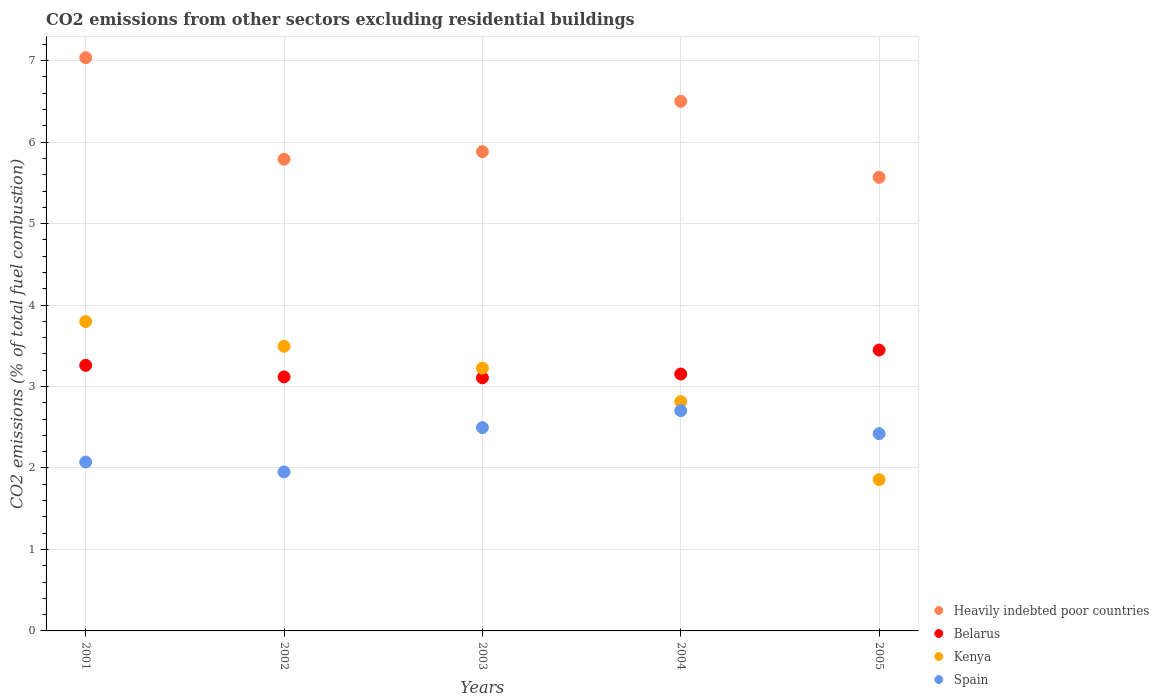How many different coloured dotlines are there?
Provide a succinct answer. 4. Is the number of dotlines equal to the number of legend labels?
Make the answer very short. Yes. What is the total CO2 emitted in Kenya in 2001?
Give a very brief answer. 3.8. Across all years, what is the maximum total CO2 emitted in Kenya?
Ensure brevity in your answer.  3.8. Across all years, what is the minimum total CO2 emitted in Spain?
Offer a terse response. 1.95. In which year was the total CO2 emitted in Spain maximum?
Keep it short and to the point. 2004. What is the total total CO2 emitted in Belarus in the graph?
Provide a succinct answer. 16.09. What is the difference between the total CO2 emitted in Spain in 2001 and that in 2003?
Make the answer very short. -0.42. What is the difference between the total CO2 emitted in Spain in 2002 and the total CO2 emitted in Belarus in 2005?
Ensure brevity in your answer.  -1.5. What is the average total CO2 emitted in Spain per year?
Keep it short and to the point. 2.33. In the year 2003, what is the difference between the total CO2 emitted in Kenya and total CO2 emitted in Spain?
Ensure brevity in your answer.  0.73. In how many years, is the total CO2 emitted in Kenya greater than 6?
Offer a very short reply. 0. What is the ratio of the total CO2 emitted in Belarus in 2002 to that in 2003?
Offer a very short reply. 1. Is the difference between the total CO2 emitted in Kenya in 2001 and 2005 greater than the difference between the total CO2 emitted in Spain in 2001 and 2005?
Your response must be concise. Yes. What is the difference between the highest and the second highest total CO2 emitted in Heavily indebted poor countries?
Your answer should be very brief. 0.54. What is the difference between the highest and the lowest total CO2 emitted in Kenya?
Offer a terse response. 1.94. Is the sum of the total CO2 emitted in Spain in 2001 and 2005 greater than the maximum total CO2 emitted in Heavily indebted poor countries across all years?
Your answer should be compact. No. Is it the case that in every year, the sum of the total CO2 emitted in Heavily indebted poor countries and total CO2 emitted in Kenya  is greater than the sum of total CO2 emitted in Spain and total CO2 emitted in Belarus?
Your response must be concise. Yes. How many dotlines are there?
Keep it short and to the point. 4. How many years are there in the graph?
Offer a very short reply. 5. Are the values on the major ticks of Y-axis written in scientific E-notation?
Provide a short and direct response. No. Does the graph contain grids?
Give a very brief answer. Yes. Where does the legend appear in the graph?
Give a very brief answer. Bottom right. What is the title of the graph?
Ensure brevity in your answer.  CO2 emissions from other sectors excluding residential buildings. What is the label or title of the Y-axis?
Your answer should be compact. CO2 emissions (% of total fuel combustion). What is the CO2 emissions (% of total fuel combustion) in Heavily indebted poor countries in 2001?
Provide a succinct answer. 7.04. What is the CO2 emissions (% of total fuel combustion) of Belarus in 2001?
Provide a short and direct response. 3.26. What is the CO2 emissions (% of total fuel combustion) of Kenya in 2001?
Make the answer very short. 3.8. What is the CO2 emissions (% of total fuel combustion) of Spain in 2001?
Offer a very short reply. 2.07. What is the CO2 emissions (% of total fuel combustion) in Heavily indebted poor countries in 2002?
Provide a succinct answer. 5.79. What is the CO2 emissions (% of total fuel combustion) in Belarus in 2002?
Your answer should be very brief. 3.12. What is the CO2 emissions (% of total fuel combustion) of Kenya in 2002?
Offer a very short reply. 3.49. What is the CO2 emissions (% of total fuel combustion) of Spain in 2002?
Make the answer very short. 1.95. What is the CO2 emissions (% of total fuel combustion) in Heavily indebted poor countries in 2003?
Make the answer very short. 5.88. What is the CO2 emissions (% of total fuel combustion) in Belarus in 2003?
Give a very brief answer. 3.11. What is the CO2 emissions (% of total fuel combustion) in Kenya in 2003?
Your response must be concise. 3.23. What is the CO2 emissions (% of total fuel combustion) of Spain in 2003?
Give a very brief answer. 2.5. What is the CO2 emissions (% of total fuel combustion) in Heavily indebted poor countries in 2004?
Your response must be concise. 6.5. What is the CO2 emissions (% of total fuel combustion) of Belarus in 2004?
Ensure brevity in your answer.  3.15. What is the CO2 emissions (% of total fuel combustion) in Kenya in 2004?
Offer a very short reply. 2.81. What is the CO2 emissions (% of total fuel combustion) in Spain in 2004?
Make the answer very short. 2.7. What is the CO2 emissions (% of total fuel combustion) in Heavily indebted poor countries in 2005?
Your answer should be compact. 5.57. What is the CO2 emissions (% of total fuel combustion) in Belarus in 2005?
Keep it short and to the point. 3.45. What is the CO2 emissions (% of total fuel combustion) in Kenya in 2005?
Keep it short and to the point. 1.86. What is the CO2 emissions (% of total fuel combustion) of Spain in 2005?
Offer a terse response. 2.42. Across all years, what is the maximum CO2 emissions (% of total fuel combustion) in Heavily indebted poor countries?
Offer a very short reply. 7.04. Across all years, what is the maximum CO2 emissions (% of total fuel combustion) of Belarus?
Make the answer very short. 3.45. Across all years, what is the maximum CO2 emissions (% of total fuel combustion) of Kenya?
Keep it short and to the point. 3.8. Across all years, what is the maximum CO2 emissions (% of total fuel combustion) of Spain?
Keep it short and to the point. 2.7. Across all years, what is the minimum CO2 emissions (% of total fuel combustion) of Heavily indebted poor countries?
Give a very brief answer. 5.57. Across all years, what is the minimum CO2 emissions (% of total fuel combustion) in Belarus?
Ensure brevity in your answer.  3.11. Across all years, what is the minimum CO2 emissions (% of total fuel combustion) of Kenya?
Offer a terse response. 1.86. Across all years, what is the minimum CO2 emissions (% of total fuel combustion) in Spain?
Offer a terse response. 1.95. What is the total CO2 emissions (% of total fuel combustion) of Heavily indebted poor countries in the graph?
Provide a succinct answer. 30.78. What is the total CO2 emissions (% of total fuel combustion) in Belarus in the graph?
Provide a succinct answer. 16.09. What is the total CO2 emissions (% of total fuel combustion) of Kenya in the graph?
Offer a terse response. 15.19. What is the total CO2 emissions (% of total fuel combustion) in Spain in the graph?
Give a very brief answer. 11.65. What is the difference between the CO2 emissions (% of total fuel combustion) in Heavily indebted poor countries in 2001 and that in 2002?
Provide a short and direct response. 1.25. What is the difference between the CO2 emissions (% of total fuel combustion) in Belarus in 2001 and that in 2002?
Offer a very short reply. 0.14. What is the difference between the CO2 emissions (% of total fuel combustion) in Kenya in 2001 and that in 2002?
Your answer should be compact. 0.3. What is the difference between the CO2 emissions (% of total fuel combustion) in Spain in 2001 and that in 2002?
Keep it short and to the point. 0.12. What is the difference between the CO2 emissions (% of total fuel combustion) in Heavily indebted poor countries in 2001 and that in 2003?
Offer a terse response. 1.15. What is the difference between the CO2 emissions (% of total fuel combustion) of Belarus in 2001 and that in 2003?
Keep it short and to the point. 0.15. What is the difference between the CO2 emissions (% of total fuel combustion) in Kenya in 2001 and that in 2003?
Provide a short and direct response. 0.57. What is the difference between the CO2 emissions (% of total fuel combustion) in Spain in 2001 and that in 2003?
Give a very brief answer. -0.42. What is the difference between the CO2 emissions (% of total fuel combustion) of Heavily indebted poor countries in 2001 and that in 2004?
Your response must be concise. 0.54. What is the difference between the CO2 emissions (% of total fuel combustion) in Belarus in 2001 and that in 2004?
Offer a terse response. 0.11. What is the difference between the CO2 emissions (% of total fuel combustion) of Kenya in 2001 and that in 2004?
Provide a short and direct response. 0.98. What is the difference between the CO2 emissions (% of total fuel combustion) of Spain in 2001 and that in 2004?
Offer a very short reply. -0.63. What is the difference between the CO2 emissions (% of total fuel combustion) of Heavily indebted poor countries in 2001 and that in 2005?
Give a very brief answer. 1.47. What is the difference between the CO2 emissions (% of total fuel combustion) of Belarus in 2001 and that in 2005?
Keep it short and to the point. -0.19. What is the difference between the CO2 emissions (% of total fuel combustion) in Kenya in 2001 and that in 2005?
Offer a very short reply. 1.94. What is the difference between the CO2 emissions (% of total fuel combustion) in Spain in 2001 and that in 2005?
Keep it short and to the point. -0.35. What is the difference between the CO2 emissions (% of total fuel combustion) of Heavily indebted poor countries in 2002 and that in 2003?
Make the answer very short. -0.09. What is the difference between the CO2 emissions (% of total fuel combustion) of Belarus in 2002 and that in 2003?
Offer a very short reply. 0.01. What is the difference between the CO2 emissions (% of total fuel combustion) in Kenya in 2002 and that in 2003?
Provide a succinct answer. 0.27. What is the difference between the CO2 emissions (% of total fuel combustion) of Spain in 2002 and that in 2003?
Provide a succinct answer. -0.54. What is the difference between the CO2 emissions (% of total fuel combustion) in Heavily indebted poor countries in 2002 and that in 2004?
Make the answer very short. -0.71. What is the difference between the CO2 emissions (% of total fuel combustion) of Belarus in 2002 and that in 2004?
Offer a terse response. -0.04. What is the difference between the CO2 emissions (% of total fuel combustion) in Kenya in 2002 and that in 2004?
Your response must be concise. 0.68. What is the difference between the CO2 emissions (% of total fuel combustion) in Spain in 2002 and that in 2004?
Offer a very short reply. -0.75. What is the difference between the CO2 emissions (% of total fuel combustion) of Heavily indebted poor countries in 2002 and that in 2005?
Make the answer very short. 0.22. What is the difference between the CO2 emissions (% of total fuel combustion) of Belarus in 2002 and that in 2005?
Provide a succinct answer. -0.33. What is the difference between the CO2 emissions (% of total fuel combustion) in Kenya in 2002 and that in 2005?
Ensure brevity in your answer.  1.64. What is the difference between the CO2 emissions (% of total fuel combustion) of Spain in 2002 and that in 2005?
Offer a terse response. -0.47. What is the difference between the CO2 emissions (% of total fuel combustion) of Heavily indebted poor countries in 2003 and that in 2004?
Your response must be concise. -0.62. What is the difference between the CO2 emissions (% of total fuel combustion) in Belarus in 2003 and that in 2004?
Offer a terse response. -0.05. What is the difference between the CO2 emissions (% of total fuel combustion) of Kenya in 2003 and that in 2004?
Your answer should be compact. 0.41. What is the difference between the CO2 emissions (% of total fuel combustion) of Spain in 2003 and that in 2004?
Give a very brief answer. -0.21. What is the difference between the CO2 emissions (% of total fuel combustion) in Heavily indebted poor countries in 2003 and that in 2005?
Make the answer very short. 0.32. What is the difference between the CO2 emissions (% of total fuel combustion) of Belarus in 2003 and that in 2005?
Ensure brevity in your answer.  -0.34. What is the difference between the CO2 emissions (% of total fuel combustion) of Kenya in 2003 and that in 2005?
Offer a terse response. 1.37. What is the difference between the CO2 emissions (% of total fuel combustion) of Spain in 2003 and that in 2005?
Your answer should be very brief. 0.07. What is the difference between the CO2 emissions (% of total fuel combustion) in Heavily indebted poor countries in 2004 and that in 2005?
Your response must be concise. 0.93. What is the difference between the CO2 emissions (% of total fuel combustion) in Belarus in 2004 and that in 2005?
Keep it short and to the point. -0.29. What is the difference between the CO2 emissions (% of total fuel combustion) in Kenya in 2004 and that in 2005?
Your answer should be compact. 0.96. What is the difference between the CO2 emissions (% of total fuel combustion) in Spain in 2004 and that in 2005?
Offer a terse response. 0.28. What is the difference between the CO2 emissions (% of total fuel combustion) in Heavily indebted poor countries in 2001 and the CO2 emissions (% of total fuel combustion) in Belarus in 2002?
Give a very brief answer. 3.92. What is the difference between the CO2 emissions (% of total fuel combustion) of Heavily indebted poor countries in 2001 and the CO2 emissions (% of total fuel combustion) of Kenya in 2002?
Your answer should be compact. 3.54. What is the difference between the CO2 emissions (% of total fuel combustion) of Heavily indebted poor countries in 2001 and the CO2 emissions (% of total fuel combustion) of Spain in 2002?
Provide a short and direct response. 5.08. What is the difference between the CO2 emissions (% of total fuel combustion) in Belarus in 2001 and the CO2 emissions (% of total fuel combustion) in Kenya in 2002?
Offer a terse response. -0.23. What is the difference between the CO2 emissions (% of total fuel combustion) of Belarus in 2001 and the CO2 emissions (% of total fuel combustion) of Spain in 2002?
Your answer should be very brief. 1.31. What is the difference between the CO2 emissions (% of total fuel combustion) of Kenya in 2001 and the CO2 emissions (% of total fuel combustion) of Spain in 2002?
Make the answer very short. 1.85. What is the difference between the CO2 emissions (% of total fuel combustion) of Heavily indebted poor countries in 2001 and the CO2 emissions (% of total fuel combustion) of Belarus in 2003?
Provide a short and direct response. 3.93. What is the difference between the CO2 emissions (% of total fuel combustion) in Heavily indebted poor countries in 2001 and the CO2 emissions (% of total fuel combustion) in Kenya in 2003?
Ensure brevity in your answer.  3.81. What is the difference between the CO2 emissions (% of total fuel combustion) in Heavily indebted poor countries in 2001 and the CO2 emissions (% of total fuel combustion) in Spain in 2003?
Keep it short and to the point. 4.54. What is the difference between the CO2 emissions (% of total fuel combustion) in Belarus in 2001 and the CO2 emissions (% of total fuel combustion) in Kenya in 2003?
Offer a very short reply. 0.03. What is the difference between the CO2 emissions (% of total fuel combustion) in Belarus in 2001 and the CO2 emissions (% of total fuel combustion) in Spain in 2003?
Provide a succinct answer. 0.76. What is the difference between the CO2 emissions (% of total fuel combustion) in Kenya in 2001 and the CO2 emissions (% of total fuel combustion) in Spain in 2003?
Offer a very short reply. 1.3. What is the difference between the CO2 emissions (% of total fuel combustion) in Heavily indebted poor countries in 2001 and the CO2 emissions (% of total fuel combustion) in Belarus in 2004?
Offer a very short reply. 3.88. What is the difference between the CO2 emissions (% of total fuel combustion) in Heavily indebted poor countries in 2001 and the CO2 emissions (% of total fuel combustion) in Kenya in 2004?
Provide a succinct answer. 4.22. What is the difference between the CO2 emissions (% of total fuel combustion) of Heavily indebted poor countries in 2001 and the CO2 emissions (% of total fuel combustion) of Spain in 2004?
Provide a succinct answer. 4.33. What is the difference between the CO2 emissions (% of total fuel combustion) of Belarus in 2001 and the CO2 emissions (% of total fuel combustion) of Kenya in 2004?
Your answer should be compact. 0.45. What is the difference between the CO2 emissions (% of total fuel combustion) in Belarus in 2001 and the CO2 emissions (% of total fuel combustion) in Spain in 2004?
Your answer should be compact. 0.56. What is the difference between the CO2 emissions (% of total fuel combustion) in Kenya in 2001 and the CO2 emissions (% of total fuel combustion) in Spain in 2004?
Offer a very short reply. 1.09. What is the difference between the CO2 emissions (% of total fuel combustion) in Heavily indebted poor countries in 2001 and the CO2 emissions (% of total fuel combustion) in Belarus in 2005?
Give a very brief answer. 3.59. What is the difference between the CO2 emissions (% of total fuel combustion) of Heavily indebted poor countries in 2001 and the CO2 emissions (% of total fuel combustion) of Kenya in 2005?
Provide a short and direct response. 5.18. What is the difference between the CO2 emissions (% of total fuel combustion) in Heavily indebted poor countries in 2001 and the CO2 emissions (% of total fuel combustion) in Spain in 2005?
Your answer should be very brief. 4.62. What is the difference between the CO2 emissions (% of total fuel combustion) in Belarus in 2001 and the CO2 emissions (% of total fuel combustion) in Kenya in 2005?
Your response must be concise. 1.4. What is the difference between the CO2 emissions (% of total fuel combustion) in Belarus in 2001 and the CO2 emissions (% of total fuel combustion) in Spain in 2005?
Your response must be concise. 0.84. What is the difference between the CO2 emissions (% of total fuel combustion) of Kenya in 2001 and the CO2 emissions (% of total fuel combustion) of Spain in 2005?
Your answer should be very brief. 1.38. What is the difference between the CO2 emissions (% of total fuel combustion) of Heavily indebted poor countries in 2002 and the CO2 emissions (% of total fuel combustion) of Belarus in 2003?
Your response must be concise. 2.68. What is the difference between the CO2 emissions (% of total fuel combustion) in Heavily indebted poor countries in 2002 and the CO2 emissions (% of total fuel combustion) in Kenya in 2003?
Ensure brevity in your answer.  2.56. What is the difference between the CO2 emissions (% of total fuel combustion) of Heavily indebted poor countries in 2002 and the CO2 emissions (% of total fuel combustion) of Spain in 2003?
Ensure brevity in your answer.  3.29. What is the difference between the CO2 emissions (% of total fuel combustion) of Belarus in 2002 and the CO2 emissions (% of total fuel combustion) of Kenya in 2003?
Offer a terse response. -0.11. What is the difference between the CO2 emissions (% of total fuel combustion) of Belarus in 2002 and the CO2 emissions (% of total fuel combustion) of Spain in 2003?
Provide a short and direct response. 0.62. What is the difference between the CO2 emissions (% of total fuel combustion) in Kenya in 2002 and the CO2 emissions (% of total fuel combustion) in Spain in 2003?
Give a very brief answer. 1. What is the difference between the CO2 emissions (% of total fuel combustion) in Heavily indebted poor countries in 2002 and the CO2 emissions (% of total fuel combustion) in Belarus in 2004?
Your answer should be very brief. 2.64. What is the difference between the CO2 emissions (% of total fuel combustion) in Heavily indebted poor countries in 2002 and the CO2 emissions (% of total fuel combustion) in Kenya in 2004?
Offer a terse response. 2.98. What is the difference between the CO2 emissions (% of total fuel combustion) of Heavily indebted poor countries in 2002 and the CO2 emissions (% of total fuel combustion) of Spain in 2004?
Keep it short and to the point. 3.09. What is the difference between the CO2 emissions (% of total fuel combustion) in Belarus in 2002 and the CO2 emissions (% of total fuel combustion) in Kenya in 2004?
Your answer should be compact. 0.3. What is the difference between the CO2 emissions (% of total fuel combustion) of Belarus in 2002 and the CO2 emissions (% of total fuel combustion) of Spain in 2004?
Make the answer very short. 0.41. What is the difference between the CO2 emissions (% of total fuel combustion) of Kenya in 2002 and the CO2 emissions (% of total fuel combustion) of Spain in 2004?
Your answer should be very brief. 0.79. What is the difference between the CO2 emissions (% of total fuel combustion) of Heavily indebted poor countries in 2002 and the CO2 emissions (% of total fuel combustion) of Belarus in 2005?
Keep it short and to the point. 2.34. What is the difference between the CO2 emissions (% of total fuel combustion) in Heavily indebted poor countries in 2002 and the CO2 emissions (% of total fuel combustion) in Kenya in 2005?
Give a very brief answer. 3.93. What is the difference between the CO2 emissions (% of total fuel combustion) of Heavily indebted poor countries in 2002 and the CO2 emissions (% of total fuel combustion) of Spain in 2005?
Offer a very short reply. 3.37. What is the difference between the CO2 emissions (% of total fuel combustion) in Belarus in 2002 and the CO2 emissions (% of total fuel combustion) in Kenya in 2005?
Provide a short and direct response. 1.26. What is the difference between the CO2 emissions (% of total fuel combustion) in Belarus in 2002 and the CO2 emissions (% of total fuel combustion) in Spain in 2005?
Offer a very short reply. 0.7. What is the difference between the CO2 emissions (% of total fuel combustion) of Kenya in 2002 and the CO2 emissions (% of total fuel combustion) of Spain in 2005?
Your response must be concise. 1.07. What is the difference between the CO2 emissions (% of total fuel combustion) of Heavily indebted poor countries in 2003 and the CO2 emissions (% of total fuel combustion) of Belarus in 2004?
Provide a succinct answer. 2.73. What is the difference between the CO2 emissions (% of total fuel combustion) in Heavily indebted poor countries in 2003 and the CO2 emissions (% of total fuel combustion) in Kenya in 2004?
Provide a succinct answer. 3.07. What is the difference between the CO2 emissions (% of total fuel combustion) of Heavily indebted poor countries in 2003 and the CO2 emissions (% of total fuel combustion) of Spain in 2004?
Your response must be concise. 3.18. What is the difference between the CO2 emissions (% of total fuel combustion) in Belarus in 2003 and the CO2 emissions (% of total fuel combustion) in Kenya in 2004?
Provide a short and direct response. 0.29. What is the difference between the CO2 emissions (% of total fuel combustion) of Belarus in 2003 and the CO2 emissions (% of total fuel combustion) of Spain in 2004?
Ensure brevity in your answer.  0.4. What is the difference between the CO2 emissions (% of total fuel combustion) in Kenya in 2003 and the CO2 emissions (% of total fuel combustion) in Spain in 2004?
Your response must be concise. 0.52. What is the difference between the CO2 emissions (% of total fuel combustion) in Heavily indebted poor countries in 2003 and the CO2 emissions (% of total fuel combustion) in Belarus in 2005?
Ensure brevity in your answer.  2.44. What is the difference between the CO2 emissions (% of total fuel combustion) of Heavily indebted poor countries in 2003 and the CO2 emissions (% of total fuel combustion) of Kenya in 2005?
Ensure brevity in your answer.  4.03. What is the difference between the CO2 emissions (% of total fuel combustion) in Heavily indebted poor countries in 2003 and the CO2 emissions (% of total fuel combustion) in Spain in 2005?
Make the answer very short. 3.46. What is the difference between the CO2 emissions (% of total fuel combustion) of Belarus in 2003 and the CO2 emissions (% of total fuel combustion) of Kenya in 2005?
Your response must be concise. 1.25. What is the difference between the CO2 emissions (% of total fuel combustion) of Belarus in 2003 and the CO2 emissions (% of total fuel combustion) of Spain in 2005?
Provide a succinct answer. 0.69. What is the difference between the CO2 emissions (% of total fuel combustion) in Kenya in 2003 and the CO2 emissions (% of total fuel combustion) in Spain in 2005?
Keep it short and to the point. 0.8. What is the difference between the CO2 emissions (% of total fuel combustion) of Heavily indebted poor countries in 2004 and the CO2 emissions (% of total fuel combustion) of Belarus in 2005?
Your response must be concise. 3.05. What is the difference between the CO2 emissions (% of total fuel combustion) of Heavily indebted poor countries in 2004 and the CO2 emissions (% of total fuel combustion) of Kenya in 2005?
Your answer should be compact. 4.64. What is the difference between the CO2 emissions (% of total fuel combustion) of Heavily indebted poor countries in 2004 and the CO2 emissions (% of total fuel combustion) of Spain in 2005?
Offer a terse response. 4.08. What is the difference between the CO2 emissions (% of total fuel combustion) of Belarus in 2004 and the CO2 emissions (% of total fuel combustion) of Kenya in 2005?
Provide a succinct answer. 1.3. What is the difference between the CO2 emissions (% of total fuel combustion) of Belarus in 2004 and the CO2 emissions (% of total fuel combustion) of Spain in 2005?
Offer a very short reply. 0.73. What is the difference between the CO2 emissions (% of total fuel combustion) of Kenya in 2004 and the CO2 emissions (% of total fuel combustion) of Spain in 2005?
Ensure brevity in your answer.  0.39. What is the average CO2 emissions (% of total fuel combustion) of Heavily indebted poor countries per year?
Your response must be concise. 6.16. What is the average CO2 emissions (% of total fuel combustion) of Belarus per year?
Give a very brief answer. 3.22. What is the average CO2 emissions (% of total fuel combustion) in Kenya per year?
Keep it short and to the point. 3.04. What is the average CO2 emissions (% of total fuel combustion) of Spain per year?
Ensure brevity in your answer.  2.33. In the year 2001, what is the difference between the CO2 emissions (% of total fuel combustion) of Heavily indebted poor countries and CO2 emissions (% of total fuel combustion) of Belarus?
Provide a succinct answer. 3.78. In the year 2001, what is the difference between the CO2 emissions (% of total fuel combustion) in Heavily indebted poor countries and CO2 emissions (% of total fuel combustion) in Kenya?
Make the answer very short. 3.24. In the year 2001, what is the difference between the CO2 emissions (% of total fuel combustion) in Heavily indebted poor countries and CO2 emissions (% of total fuel combustion) in Spain?
Give a very brief answer. 4.96. In the year 2001, what is the difference between the CO2 emissions (% of total fuel combustion) of Belarus and CO2 emissions (% of total fuel combustion) of Kenya?
Your answer should be very brief. -0.54. In the year 2001, what is the difference between the CO2 emissions (% of total fuel combustion) of Belarus and CO2 emissions (% of total fuel combustion) of Spain?
Provide a succinct answer. 1.19. In the year 2001, what is the difference between the CO2 emissions (% of total fuel combustion) of Kenya and CO2 emissions (% of total fuel combustion) of Spain?
Your answer should be compact. 1.72. In the year 2002, what is the difference between the CO2 emissions (% of total fuel combustion) of Heavily indebted poor countries and CO2 emissions (% of total fuel combustion) of Belarus?
Your answer should be compact. 2.67. In the year 2002, what is the difference between the CO2 emissions (% of total fuel combustion) in Heavily indebted poor countries and CO2 emissions (% of total fuel combustion) in Kenya?
Provide a short and direct response. 2.3. In the year 2002, what is the difference between the CO2 emissions (% of total fuel combustion) in Heavily indebted poor countries and CO2 emissions (% of total fuel combustion) in Spain?
Your response must be concise. 3.84. In the year 2002, what is the difference between the CO2 emissions (% of total fuel combustion) in Belarus and CO2 emissions (% of total fuel combustion) in Kenya?
Your answer should be compact. -0.38. In the year 2002, what is the difference between the CO2 emissions (% of total fuel combustion) in Belarus and CO2 emissions (% of total fuel combustion) in Spain?
Your response must be concise. 1.17. In the year 2002, what is the difference between the CO2 emissions (% of total fuel combustion) in Kenya and CO2 emissions (% of total fuel combustion) in Spain?
Provide a succinct answer. 1.54. In the year 2003, what is the difference between the CO2 emissions (% of total fuel combustion) of Heavily indebted poor countries and CO2 emissions (% of total fuel combustion) of Belarus?
Your answer should be very brief. 2.78. In the year 2003, what is the difference between the CO2 emissions (% of total fuel combustion) in Heavily indebted poor countries and CO2 emissions (% of total fuel combustion) in Kenya?
Keep it short and to the point. 2.66. In the year 2003, what is the difference between the CO2 emissions (% of total fuel combustion) in Heavily indebted poor countries and CO2 emissions (% of total fuel combustion) in Spain?
Provide a succinct answer. 3.39. In the year 2003, what is the difference between the CO2 emissions (% of total fuel combustion) of Belarus and CO2 emissions (% of total fuel combustion) of Kenya?
Give a very brief answer. -0.12. In the year 2003, what is the difference between the CO2 emissions (% of total fuel combustion) of Belarus and CO2 emissions (% of total fuel combustion) of Spain?
Your response must be concise. 0.61. In the year 2003, what is the difference between the CO2 emissions (% of total fuel combustion) of Kenya and CO2 emissions (% of total fuel combustion) of Spain?
Offer a terse response. 0.73. In the year 2004, what is the difference between the CO2 emissions (% of total fuel combustion) of Heavily indebted poor countries and CO2 emissions (% of total fuel combustion) of Belarus?
Provide a short and direct response. 3.35. In the year 2004, what is the difference between the CO2 emissions (% of total fuel combustion) of Heavily indebted poor countries and CO2 emissions (% of total fuel combustion) of Kenya?
Your answer should be compact. 3.69. In the year 2004, what is the difference between the CO2 emissions (% of total fuel combustion) in Heavily indebted poor countries and CO2 emissions (% of total fuel combustion) in Spain?
Offer a very short reply. 3.8. In the year 2004, what is the difference between the CO2 emissions (% of total fuel combustion) in Belarus and CO2 emissions (% of total fuel combustion) in Kenya?
Give a very brief answer. 0.34. In the year 2004, what is the difference between the CO2 emissions (% of total fuel combustion) of Belarus and CO2 emissions (% of total fuel combustion) of Spain?
Give a very brief answer. 0.45. In the year 2004, what is the difference between the CO2 emissions (% of total fuel combustion) of Kenya and CO2 emissions (% of total fuel combustion) of Spain?
Your response must be concise. 0.11. In the year 2005, what is the difference between the CO2 emissions (% of total fuel combustion) in Heavily indebted poor countries and CO2 emissions (% of total fuel combustion) in Belarus?
Provide a succinct answer. 2.12. In the year 2005, what is the difference between the CO2 emissions (% of total fuel combustion) in Heavily indebted poor countries and CO2 emissions (% of total fuel combustion) in Kenya?
Your answer should be very brief. 3.71. In the year 2005, what is the difference between the CO2 emissions (% of total fuel combustion) of Heavily indebted poor countries and CO2 emissions (% of total fuel combustion) of Spain?
Offer a very short reply. 3.15. In the year 2005, what is the difference between the CO2 emissions (% of total fuel combustion) in Belarus and CO2 emissions (% of total fuel combustion) in Kenya?
Ensure brevity in your answer.  1.59. In the year 2005, what is the difference between the CO2 emissions (% of total fuel combustion) in Belarus and CO2 emissions (% of total fuel combustion) in Spain?
Offer a terse response. 1.03. In the year 2005, what is the difference between the CO2 emissions (% of total fuel combustion) in Kenya and CO2 emissions (% of total fuel combustion) in Spain?
Provide a short and direct response. -0.56. What is the ratio of the CO2 emissions (% of total fuel combustion) of Heavily indebted poor countries in 2001 to that in 2002?
Make the answer very short. 1.22. What is the ratio of the CO2 emissions (% of total fuel combustion) in Belarus in 2001 to that in 2002?
Your response must be concise. 1.05. What is the ratio of the CO2 emissions (% of total fuel combustion) of Kenya in 2001 to that in 2002?
Offer a very short reply. 1.09. What is the ratio of the CO2 emissions (% of total fuel combustion) of Spain in 2001 to that in 2002?
Offer a terse response. 1.06. What is the ratio of the CO2 emissions (% of total fuel combustion) in Heavily indebted poor countries in 2001 to that in 2003?
Your response must be concise. 1.2. What is the ratio of the CO2 emissions (% of total fuel combustion) of Belarus in 2001 to that in 2003?
Provide a succinct answer. 1.05. What is the ratio of the CO2 emissions (% of total fuel combustion) in Kenya in 2001 to that in 2003?
Offer a very short reply. 1.18. What is the ratio of the CO2 emissions (% of total fuel combustion) in Spain in 2001 to that in 2003?
Ensure brevity in your answer.  0.83. What is the ratio of the CO2 emissions (% of total fuel combustion) of Heavily indebted poor countries in 2001 to that in 2004?
Keep it short and to the point. 1.08. What is the ratio of the CO2 emissions (% of total fuel combustion) in Belarus in 2001 to that in 2004?
Your response must be concise. 1.03. What is the ratio of the CO2 emissions (% of total fuel combustion) in Kenya in 2001 to that in 2004?
Your response must be concise. 1.35. What is the ratio of the CO2 emissions (% of total fuel combustion) of Spain in 2001 to that in 2004?
Your answer should be compact. 0.77. What is the ratio of the CO2 emissions (% of total fuel combustion) of Heavily indebted poor countries in 2001 to that in 2005?
Make the answer very short. 1.26. What is the ratio of the CO2 emissions (% of total fuel combustion) in Belarus in 2001 to that in 2005?
Provide a succinct answer. 0.95. What is the ratio of the CO2 emissions (% of total fuel combustion) of Kenya in 2001 to that in 2005?
Offer a very short reply. 2.05. What is the ratio of the CO2 emissions (% of total fuel combustion) of Spain in 2001 to that in 2005?
Give a very brief answer. 0.86. What is the ratio of the CO2 emissions (% of total fuel combustion) of Heavily indebted poor countries in 2002 to that in 2003?
Provide a short and direct response. 0.98. What is the ratio of the CO2 emissions (% of total fuel combustion) of Kenya in 2002 to that in 2003?
Offer a very short reply. 1.08. What is the ratio of the CO2 emissions (% of total fuel combustion) in Spain in 2002 to that in 2003?
Your response must be concise. 0.78. What is the ratio of the CO2 emissions (% of total fuel combustion) of Heavily indebted poor countries in 2002 to that in 2004?
Your answer should be compact. 0.89. What is the ratio of the CO2 emissions (% of total fuel combustion) in Kenya in 2002 to that in 2004?
Ensure brevity in your answer.  1.24. What is the ratio of the CO2 emissions (% of total fuel combustion) in Spain in 2002 to that in 2004?
Your response must be concise. 0.72. What is the ratio of the CO2 emissions (% of total fuel combustion) of Belarus in 2002 to that in 2005?
Ensure brevity in your answer.  0.9. What is the ratio of the CO2 emissions (% of total fuel combustion) in Kenya in 2002 to that in 2005?
Provide a short and direct response. 1.88. What is the ratio of the CO2 emissions (% of total fuel combustion) of Spain in 2002 to that in 2005?
Give a very brief answer. 0.81. What is the ratio of the CO2 emissions (% of total fuel combustion) of Heavily indebted poor countries in 2003 to that in 2004?
Provide a succinct answer. 0.91. What is the ratio of the CO2 emissions (% of total fuel combustion) in Kenya in 2003 to that in 2004?
Provide a short and direct response. 1.15. What is the ratio of the CO2 emissions (% of total fuel combustion) in Heavily indebted poor countries in 2003 to that in 2005?
Provide a short and direct response. 1.06. What is the ratio of the CO2 emissions (% of total fuel combustion) in Belarus in 2003 to that in 2005?
Offer a terse response. 0.9. What is the ratio of the CO2 emissions (% of total fuel combustion) in Kenya in 2003 to that in 2005?
Provide a succinct answer. 1.74. What is the ratio of the CO2 emissions (% of total fuel combustion) in Spain in 2003 to that in 2005?
Give a very brief answer. 1.03. What is the ratio of the CO2 emissions (% of total fuel combustion) in Heavily indebted poor countries in 2004 to that in 2005?
Provide a short and direct response. 1.17. What is the ratio of the CO2 emissions (% of total fuel combustion) of Belarus in 2004 to that in 2005?
Your response must be concise. 0.91. What is the ratio of the CO2 emissions (% of total fuel combustion) of Kenya in 2004 to that in 2005?
Provide a short and direct response. 1.52. What is the ratio of the CO2 emissions (% of total fuel combustion) in Spain in 2004 to that in 2005?
Ensure brevity in your answer.  1.12. What is the difference between the highest and the second highest CO2 emissions (% of total fuel combustion) in Heavily indebted poor countries?
Your answer should be compact. 0.54. What is the difference between the highest and the second highest CO2 emissions (% of total fuel combustion) of Belarus?
Provide a succinct answer. 0.19. What is the difference between the highest and the second highest CO2 emissions (% of total fuel combustion) of Kenya?
Ensure brevity in your answer.  0.3. What is the difference between the highest and the second highest CO2 emissions (% of total fuel combustion) of Spain?
Make the answer very short. 0.21. What is the difference between the highest and the lowest CO2 emissions (% of total fuel combustion) of Heavily indebted poor countries?
Give a very brief answer. 1.47. What is the difference between the highest and the lowest CO2 emissions (% of total fuel combustion) in Belarus?
Make the answer very short. 0.34. What is the difference between the highest and the lowest CO2 emissions (% of total fuel combustion) in Kenya?
Give a very brief answer. 1.94. What is the difference between the highest and the lowest CO2 emissions (% of total fuel combustion) of Spain?
Offer a very short reply. 0.75. 